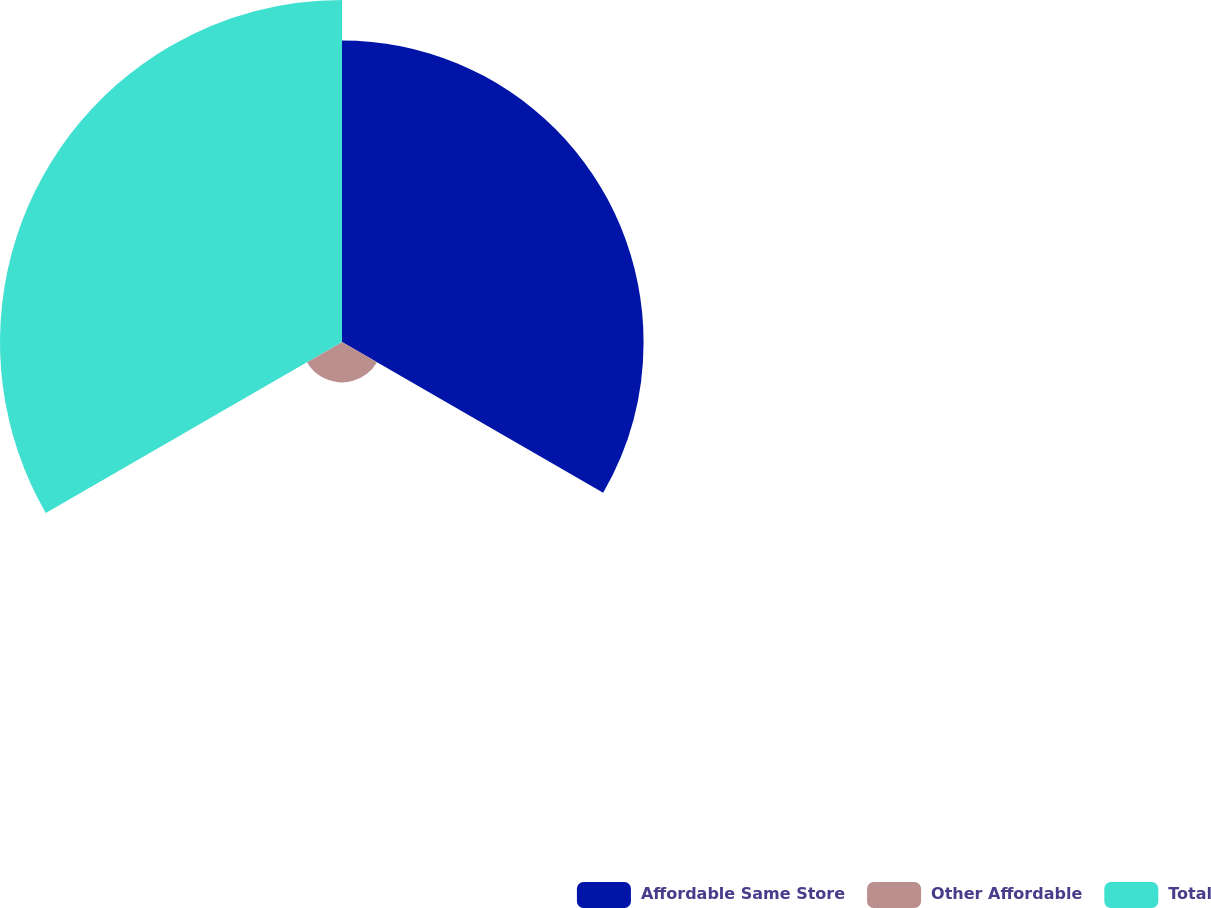<chart> <loc_0><loc_0><loc_500><loc_500><pie_chart><fcel>Affordable Same Store<fcel>Other Affordable<fcel>Total<nl><fcel>44.09%<fcel>5.91%<fcel>50.0%<nl></chart> 